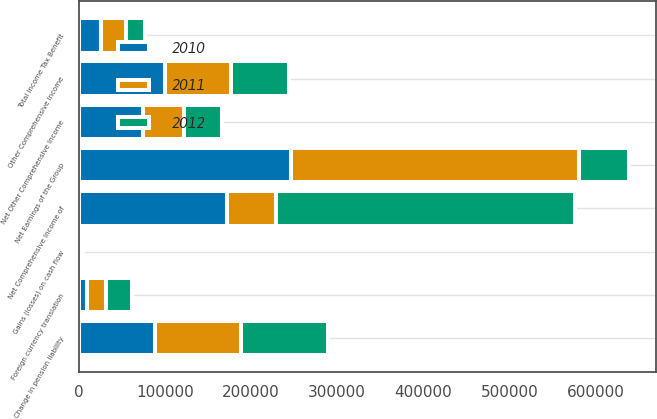<chart> <loc_0><loc_0><loc_500><loc_500><stacked_bar_chart><ecel><fcel>Net Earnings of the Group<fcel>Foreign currency translation<fcel>Change in pension liability<fcel>Gains (losses) on cash flow<fcel>Other Comprehensive Income<fcel>Total Income Tax Benefit<fcel>Net Other Comprehensive Income<fcel>Net Comprehensive Income of<nl><fcel>2012<fcel>57491.5<fcel>30038<fcel>100385<fcel>3567<fcel>66780<fcel>22431<fcel>44349<fcel>346605<nl><fcel>2011<fcel>335221<fcel>22524<fcel>99881<fcel>137<fcel>77494<fcel>29291<fcel>48203<fcel>57491.5<nl><fcel>2010<fcel>246287<fcel>9338<fcel>89091<fcel>1444<fcel>99873<fcel>25647<fcel>74226<fcel>172061<nl></chart> 